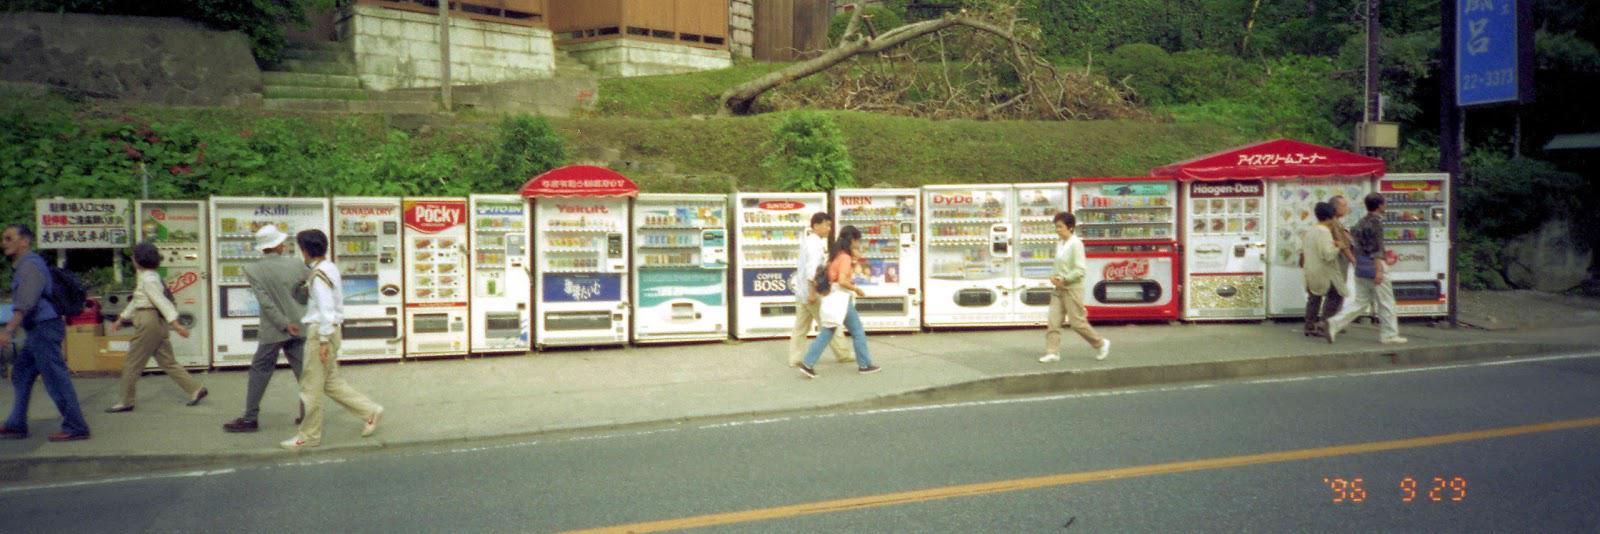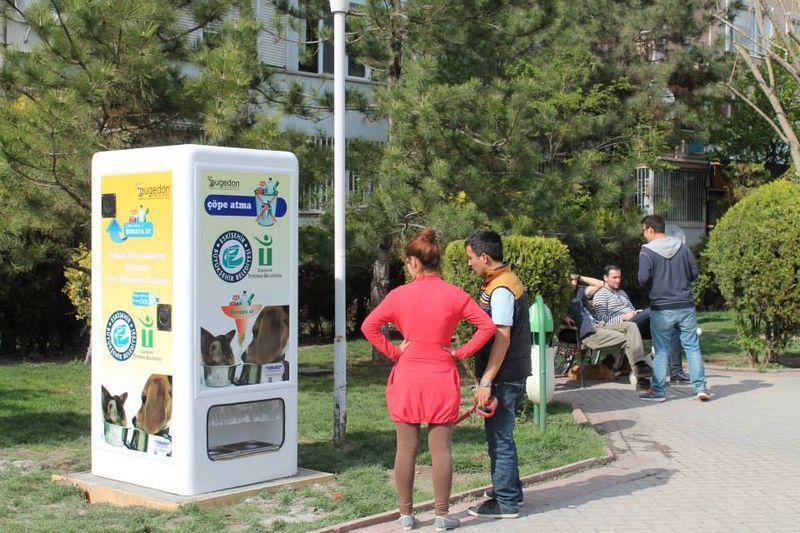The first image is the image on the left, the second image is the image on the right. For the images displayed, is the sentence "There is at least one person standing outside near the machines in the image on the right." factually correct? Answer yes or no. Yes. The first image is the image on the left, the second image is the image on the right. Considering the images on both sides, is "A standing person is visible only at the far end of a long row of vending machines." valid? Answer yes or no. No. 